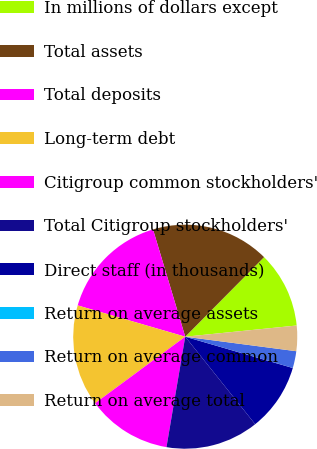<chart> <loc_0><loc_0><loc_500><loc_500><pie_chart><fcel>In millions of dollars except<fcel>Total assets<fcel>Total deposits<fcel>Long-term debt<fcel>Citigroup common stockholders'<fcel>Total Citigroup stockholders'<fcel>Direct staff (in thousands)<fcel>Return on average assets<fcel>Return on average common<fcel>Return on average total<nl><fcel>10.98%<fcel>17.07%<fcel>15.85%<fcel>14.63%<fcel>12.2%<fcel>13.41%<fcel>9.76%<fcel>0.0%<fcel>2.44%<fcel>3.66%<nl></chart> 